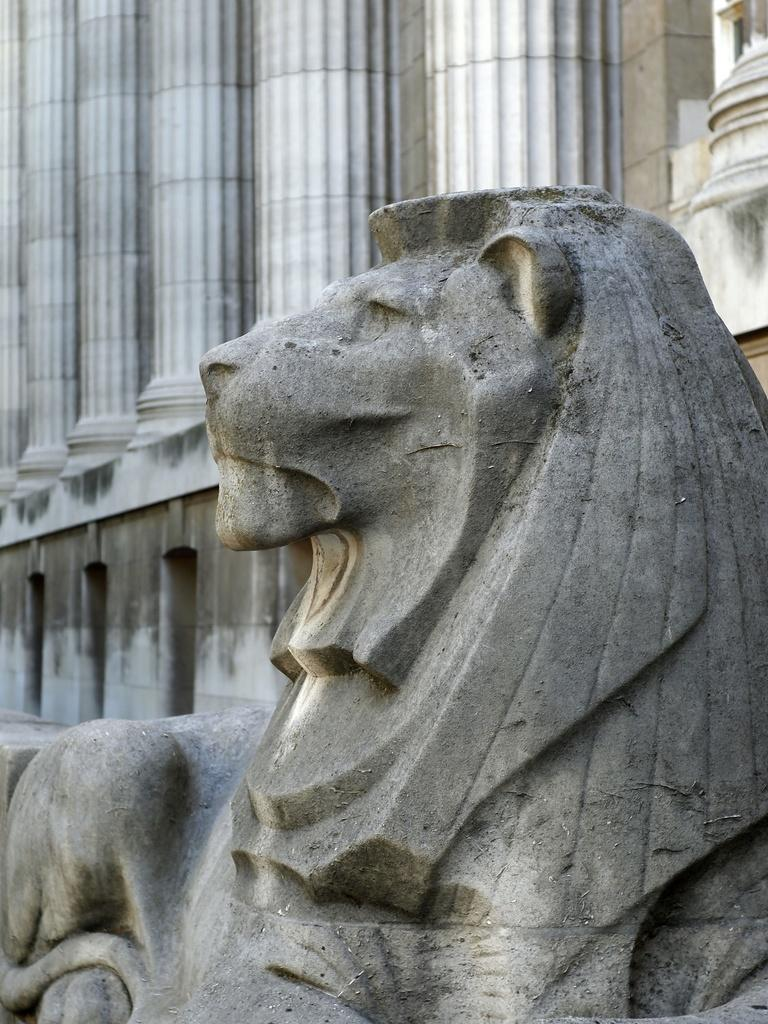What is the main subject of the image? There is a statue of an animal in the image. What can be seen beneath the statue? The ground is visible in the image. What architectural feature is present in the image? There is a wall with pillars in the image. How many pairs of shoes are hanging on the wall in the image? There are no shoes present in the image; it features a statue of an animal and a wall with pillars. What type of kettle is visible on the ground in the image? There is no kettle present in the image; it only features a statue of an animal, the ground, and a wall with pillars. 